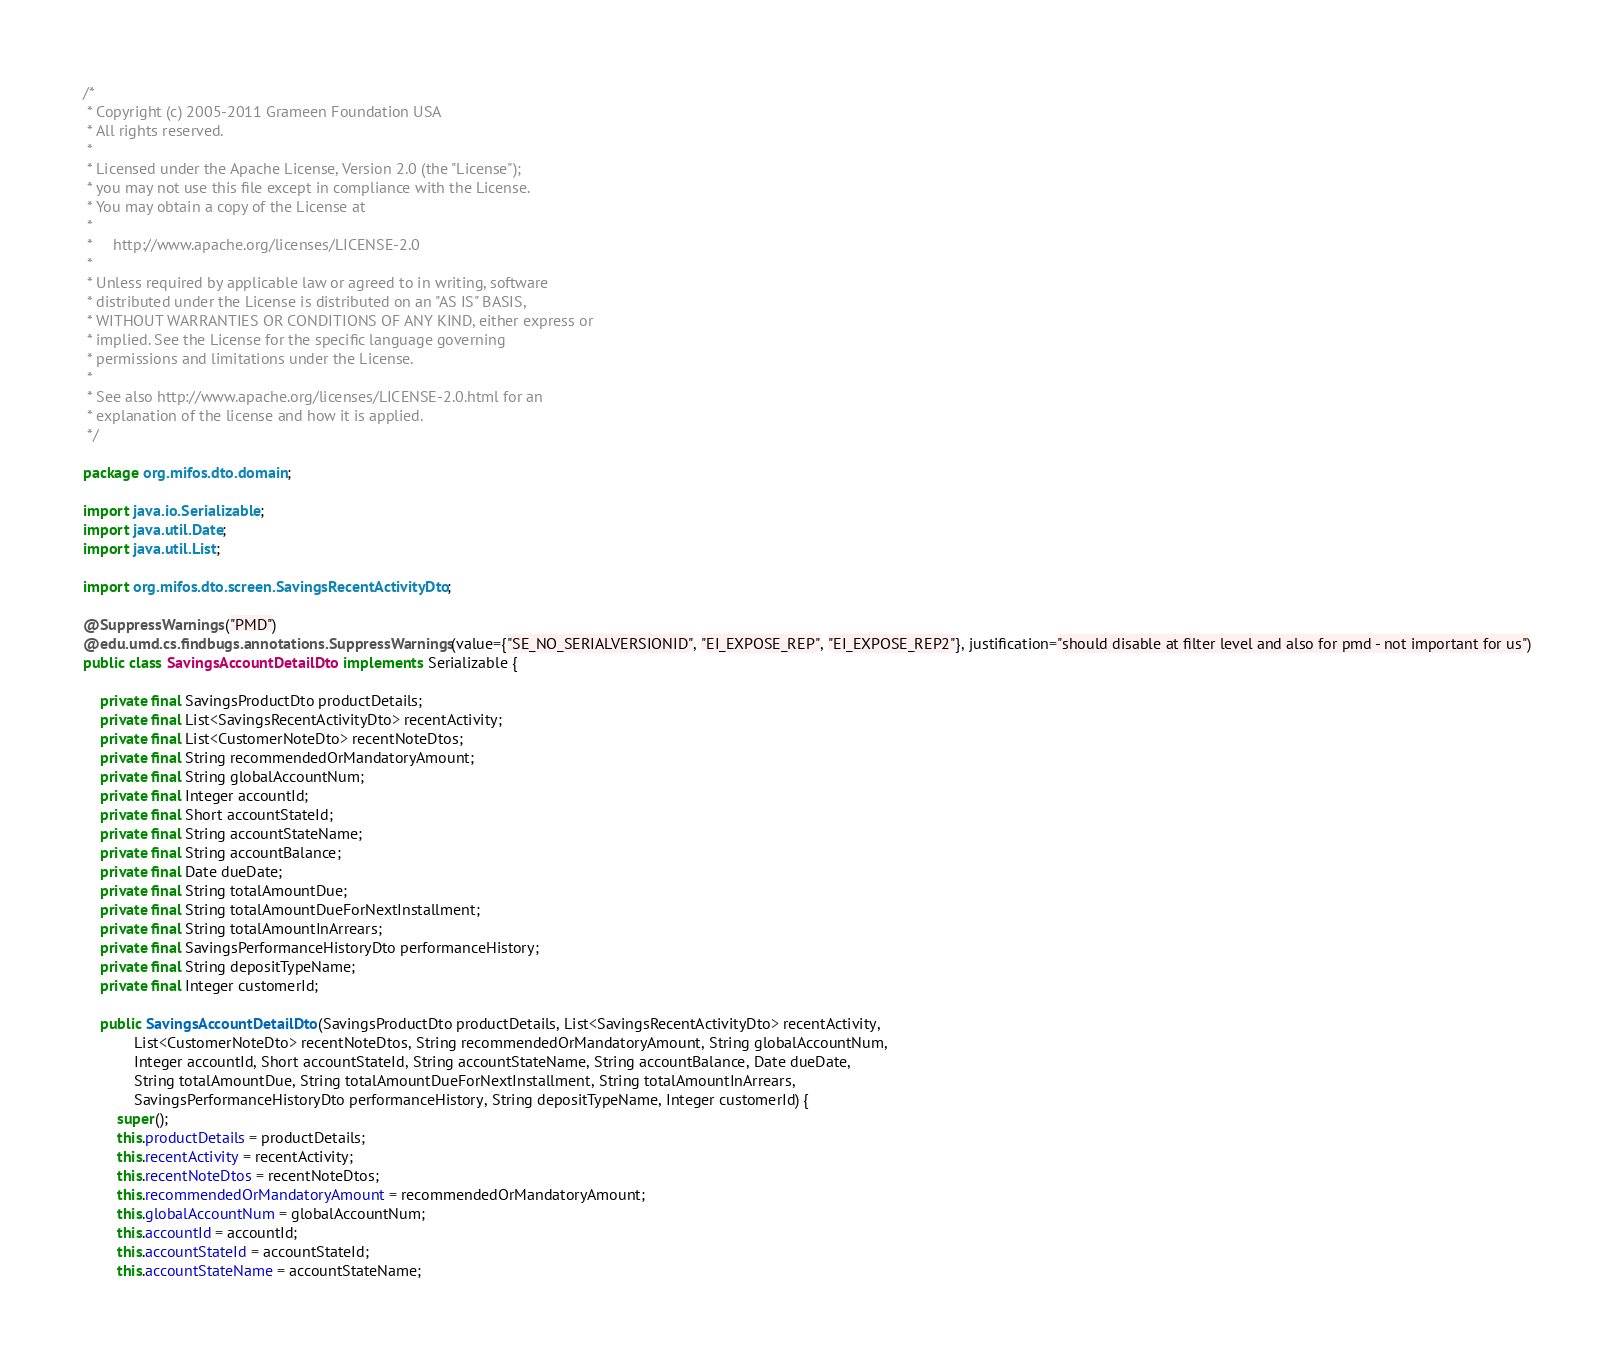<code> <loc_0><loc_0><loc_500><loc_500><_Java_>/*
 * Copyright (c) 2005-2011 Grameen Foundation USA
 * All rights reserved.
 *
 * Licensed under the Apache License, Version 2.0 (the "License");
 * you may not use this file except in compliance with the License.
 * You may obtain a copy of the License at
 *
 *     http://www.apache.org/licenses/LICENSE-2.0
 *
 * Unless required by applicable law or agreed to in writing, software
 * distributed under the License is distributed on an "AS IS" BASIS,
 * WITHOUT WARRANTIES OR CONDITIONS OF ANY KIND, either express or
 * implied. See the License for the specific language governing
 * permissions and limitations under the License.
 *
 * See also http://www.apache.org/licenses/LICENSE-2.0.html for an
 * explanation of the license and how it is applied.
 */

package org.mifos.dto.domain;

import java.io.Serializable;
import java.util.Date;
import java.util.List;

import org.mifos.dto.screen.SavingsRecentActivityDto;

@SuppressWarnings("PMD")
@edu.umd.cs.findbugs.annotations.SuppressWarnings(value={"SE_NO_SERIALVERSIONID", "EI_EXPOSE_REP", "EI_EXPOSE_REP2"}, justification="should disable at filter level and also for pmd - not important for us")
public class SavingsAccountDetailDto implements Serializable {

    private final SavingsProductDto productDetails;
    private final List<SavingsRecentActivityDto> recentActivity;
    private final List<CustomerNoteDto> recentNoteDtos;
    private final String recommendedOrMandatoryAmount;
    private final String globalAccountNum;
    private final Integer accountId;
    private final Short accountStateId;
    private final String accountStateName;
    private final String accountBalance;
    private final Date dueDate;
    private final String totalAmountDue;
    private final String totalAmountDueForNextInstallment;
    private final String totalAmountInArrears;
    private final SavingsPerformanceHistoryDto performanceHistory;
    private final String depositTypeName;
    private final Integer customerId;

    public SavingsAccountDetailDto(SavingsProductDto productDetails, List<SavingsRecentActivityDto> recentActivity,
            List<CustomerNoteDto> recentNoteDtos, String recommendedOrMandatoryAmount, String globalAccountNum,
            Integer accountId, Short accountStateId, String accountStateName, String accountBalance, Date dueDate,
            String totalAmountDue, String totalAmountDueForNextInstallment, String totalAmountInArrears,
            SavingsPerformanceHistoryDto performanceHistory, String depositTypeName, Integer customerId) {
        super();
        this.productDetails = productDetails;
        this.recentActivity = recentActivity;
        this.recentNoteDtos = recentNoteDtos;
        this.recommendedOrMandatoryAmount = recommendedOrMandatoryAmount;
        this.globalAccountNum = globalAccountNum;
        this.accountId = accountId;
        this.accountStateId = accountStateId;
        this.accountStateName = accountStateName;</code> 